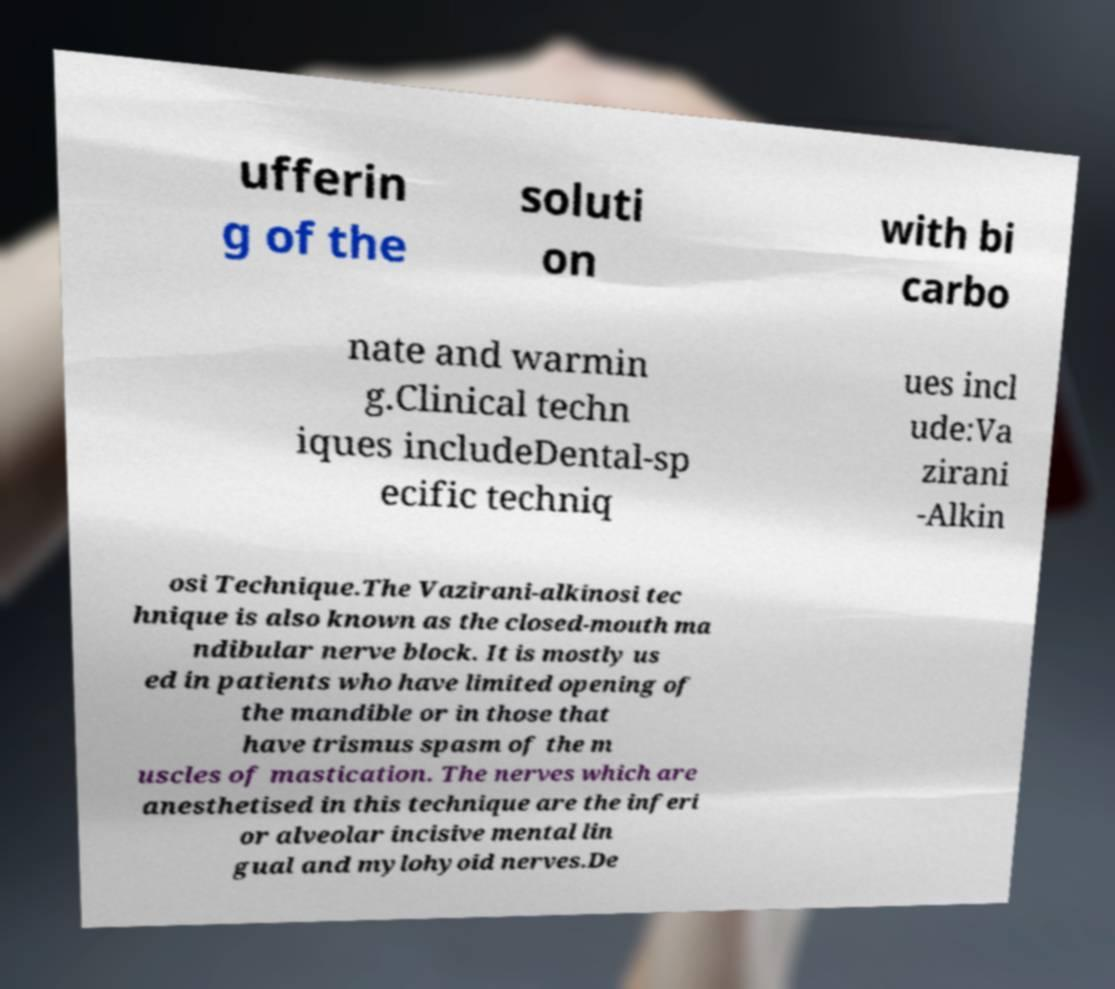For documentation purposes, I need the text within this image transcribed. Could you provide that? ufferin g of the soluti on with bi carbo nate and warmin g.Clinical techn iques includeDental-sp ecific techniq ues incl ude:Va zirani -Alkin osi Technique.The Vazirani-alkinosi tec hnique is also known as the closed-mouth ma ndibular nerve block. It is mostly us ed in patients who have limited opening of the mandible or in those that have trismus spasm of the m uscles of mastication. The nerves which are anesthetised in this technique are the inferi or alveolar incisive mental lin gual and mylohyoid nerves.De 